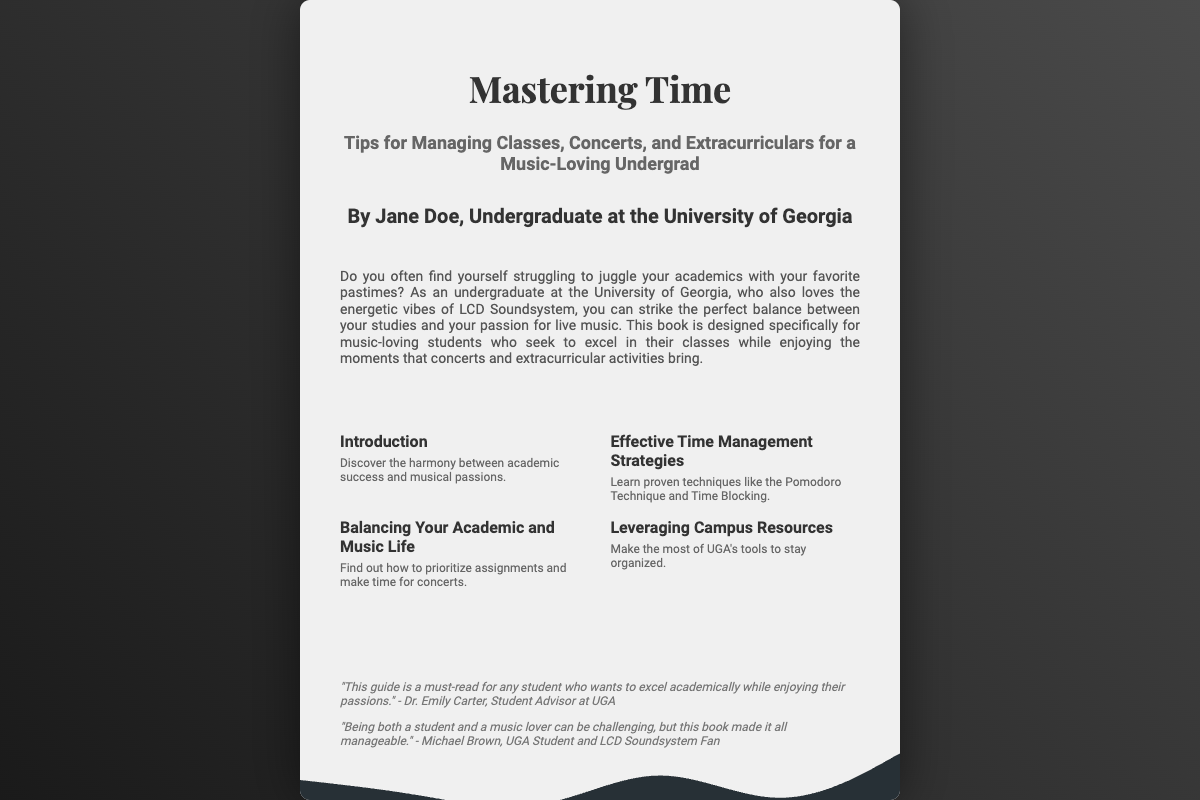What is the title of the book? The title of the book is prominently displayed on the cover, highlighted as "Mastering Time."
Answer: Mastering Time Who is the author of the book? The author is mentioned below the subtitle, providing their name as "Jane Doe."
Answer: Jane Doe What is the subtitle of the book? The subtitle is included under the title, explaining the book's focus as "Tips for Managing Classes, Concerts, and Extracurriculars for a Music-Loving Undergrad."
Answer: Tips for Managing Classes, Concerts, and Extracurriculars for a Music-Loving Undergrad What is the main theme of the book's blurb? The blurb gives insight into the book's purpose, describing the struggle of managing academics with music-related activities.
Answer: Balancing academics and music How many sections are mentioned on the cover? The cover lists four distinct sections, detailing different topics that the book covers.
Answer: Four Which time management technique is specifically mentioned? One of the techniques highlighted in the book is called the Pomodoro Technique, used for effective time management.
Answer: Pomodoro Technique How does the book propose students manage their time? The book proposes using techniques like Time Blocking to help manage time effectively.
Answer: Time Blocking What campus resources does the book suggest leveraging? The book encourages utilizing UGA's tools to help students stay organized throughout their studies.
Answer: UGA's tools Who endorsed the book? The endorsement section features two individuals, highlighting a student advisor and a UGA student.
Answer: Dr. Emily Carter and Michael Brown 